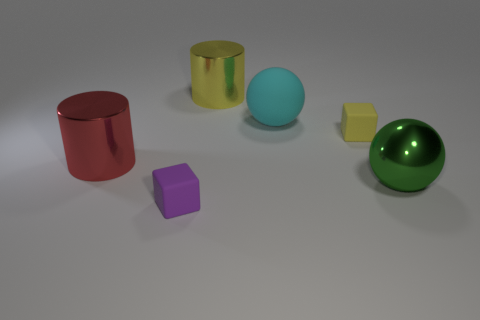What is the size of the yellow rubber block that is to the right of the large object to the left of the thing in front of the large green object?
Make the answer very short. Small. What is the shape of the big metallic thing that is in front of the big yellow shiny cylinder and on the right side of the purple cube?
Offer a terse response. Sphere. Are there the same number of yellow rubber blocks that are in front of the large red cylinder and yellow things behind the big matte ball?
Make the answer very short. No. Are there any cylinders made of the same material as the large green ball?
Keep it short and to the point. Yes. Is the small cube to the left of the large matte sphere made of the same material as the big green thing?
Provide a short and direct response. No. There is a object that is behind the green metallic thing and on the left side of the yellow metallic object; what size is it?
Your response must be concise. Large. What color is the matte ball?
Offer a terse response. Cyan. How many small matte things are there?
Ensure brevity in your answer.  2. Does the big cyan thing that is in front of the large yellow shiny object have the same shape as the tiny rubber object to the right of the tiny purple rubber object?
Ensure brevity in your answer.  No. What is the color of the rubber thing left of the large metallic cylinder that is behind the small rubber thing right of the yellow metallic cylinder?
Your answer should be very brief. Purple. 